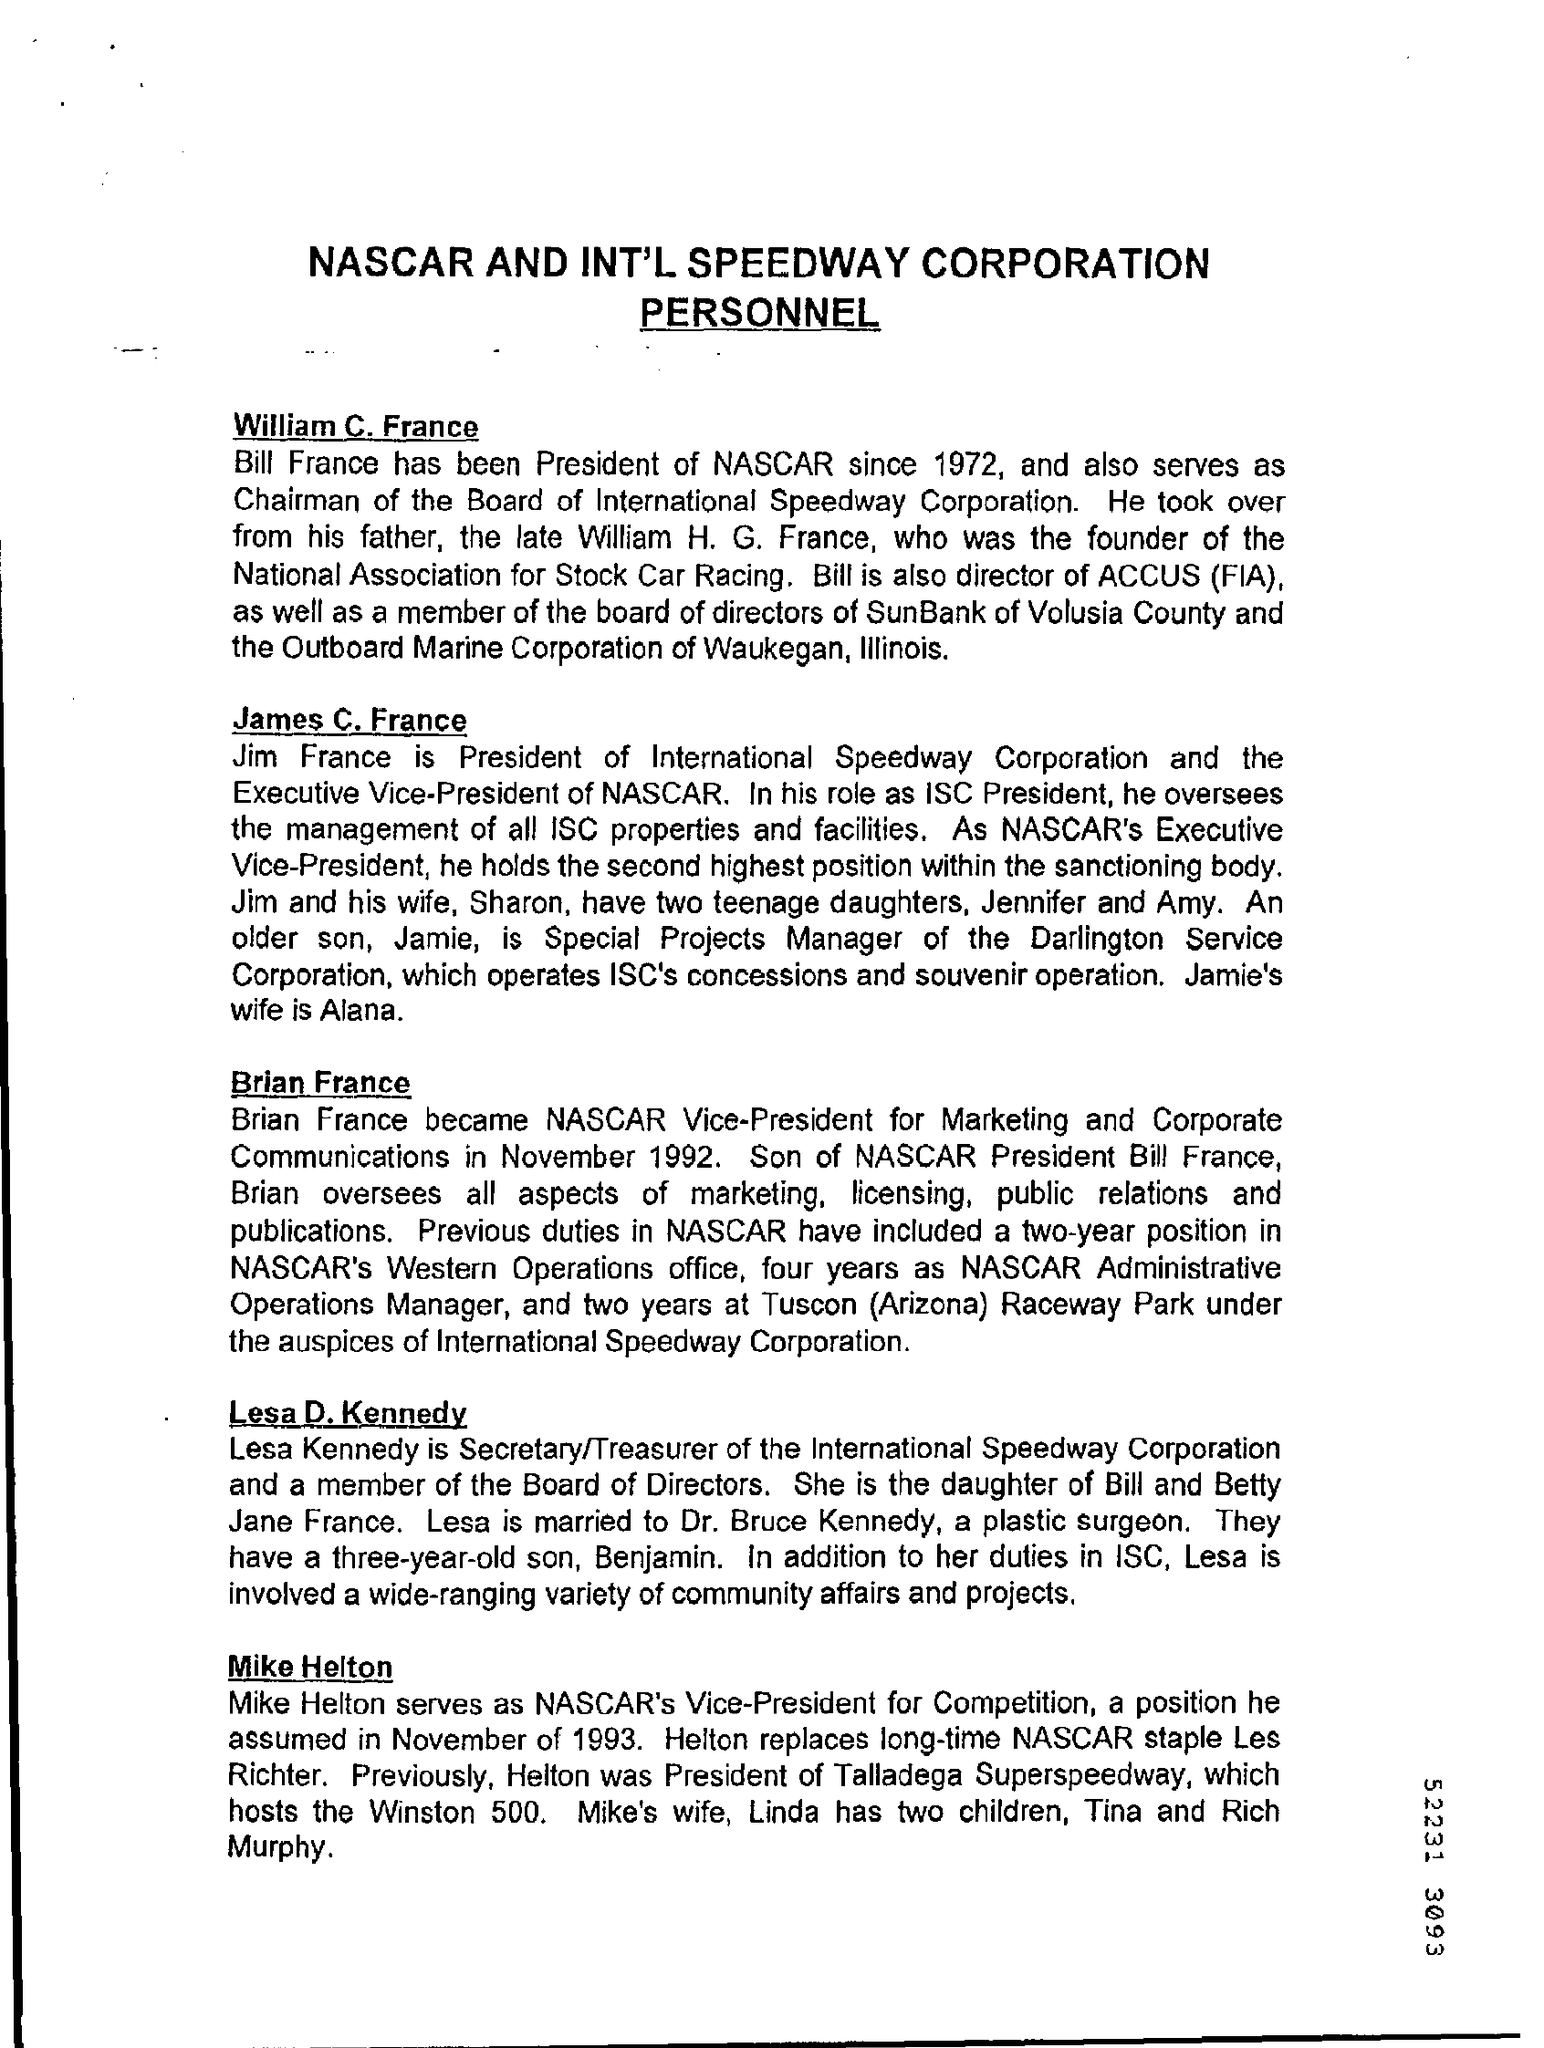Indicate a few pertinent items in this graphic. Brian France is the son of Bill France. In 1972, Bill France became the president of NASCAR. 